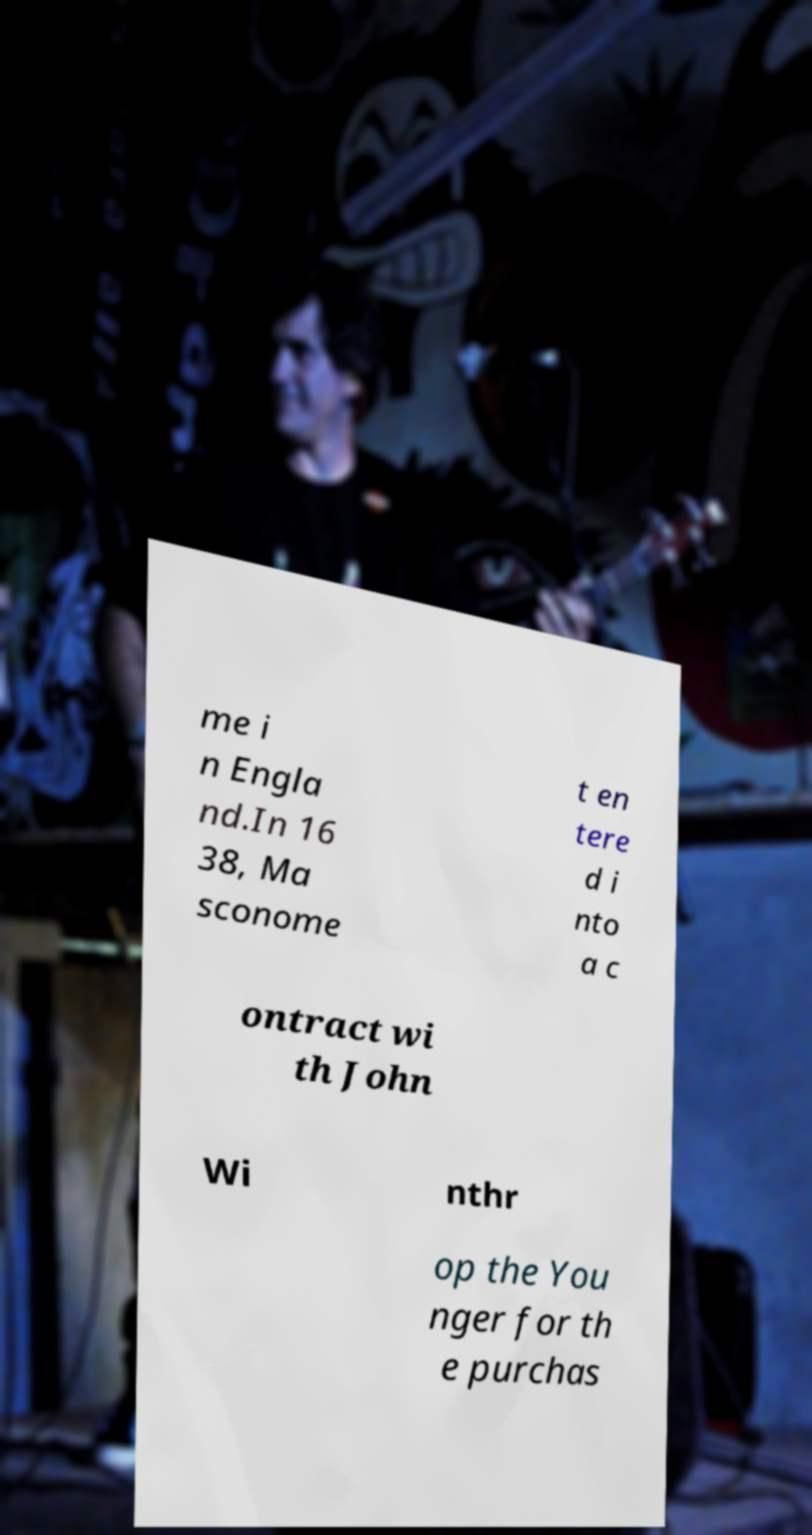Please read and relay the text visible in this image. What does it say? me i n Engla nd.In 16 38, Ma sconome t en tere d i nto a c ontract wi th John Wi nthr op the You nger for th e purchas 